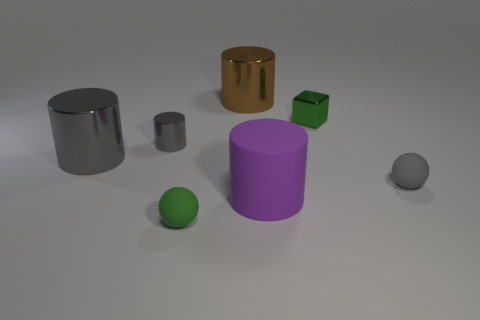Subtract all green cylinders. Subtract all green spheres. How many cylinders are left? 4 Add 3 small balls. How many objects exist? 10 Subtract all balls. How many objects are left? 5 Add 5 large purple things. How many large purple things are left? 6 Add 5 purple objects. How many purple objects exist? 6 Subtract 0 blue balls. How many objects are left? 7 Subtract all red shiny cylinders. Subtract all gray metal cylinders. How many objects are left? 5 